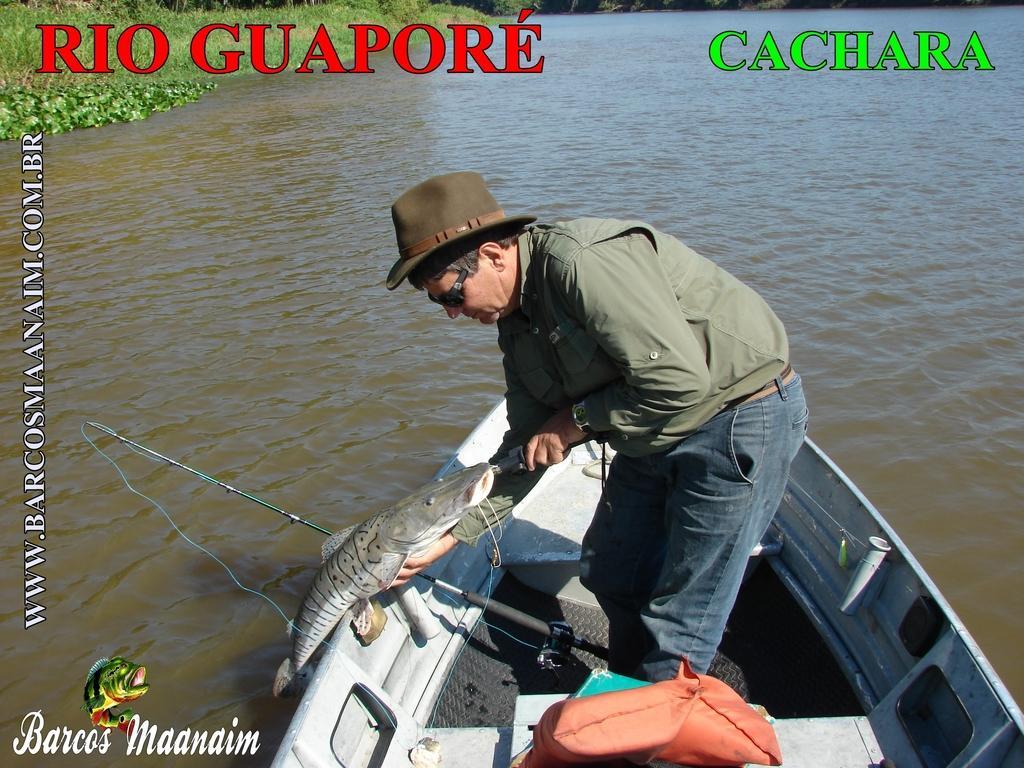Could you give a brief overview of what you see in this image? This is the man holding a fish and standing in the boat. He wore a cap, goggles, jerkin, wrist watch and trouser. This looks like a fishing rod. I think this is the life jacket, which is placed in the boat. This boat is on the water. I think this is the grass. I can see the watermarks on the image. 